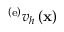Convert formula to latex. <formula><loc_0><loc_0><loc_500><loc_500>{ { \Pi } ^ { \left ( e \right ) } } v _ { h } \left ( { x } \right )</formula> 